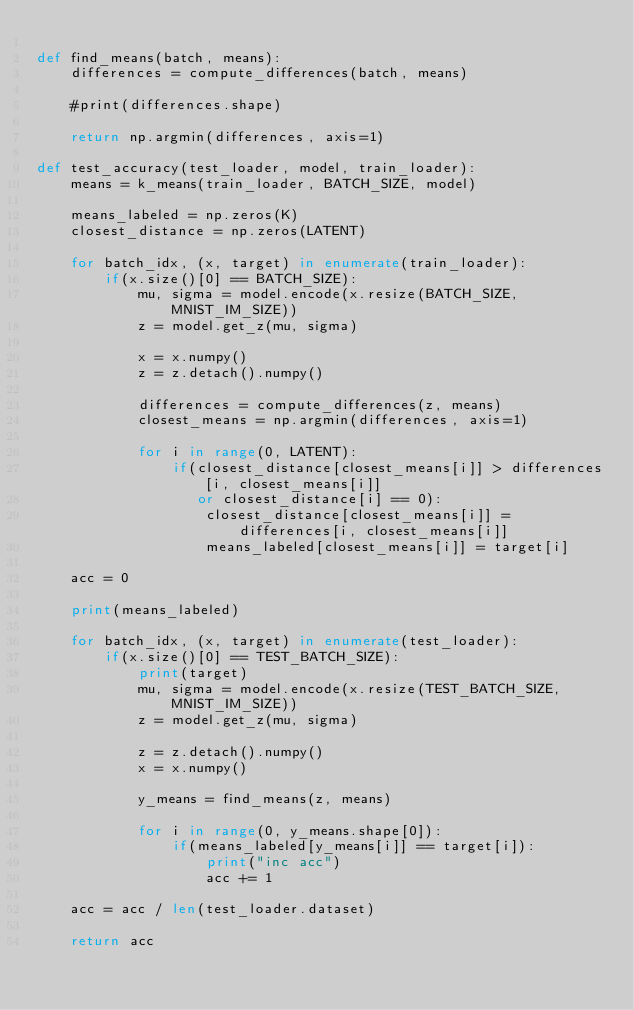<code> <loc_0><loc_0><loc_500><loc_500><_Python_>
def find_means(batch, means):
    differences = compute_differences(batch, means)

    #print(differences.shape)

    return np.argmin(differences, axis=1)

def test_accuracy(test_loader, model, train_loader):
    means = k_means(train_loader, BATCH_SIZE, model)

    means_labeled = np.zeros(K)
    closest_distance = np.zeros(LATENT)

    for batch_idx, (x, target) in enumerate(train_loader):
        if(x.size()[0] == BATCH_SIZE):
            mu, sigma = model.encode(x.resize(BATCH_SIZE, MNIST_IM_SIZE))
            z = model.get_z(mu, sigma)

            x = x.numpy()
            z = z.detach().numpy()

            differences = compute_differences(z, means)
            closest_means = np.argmin(differences, axis=1)

            for i in range(0, LATENT):
                if(closest_distance[closest_means[i]] > differences[i, closest_means[i]]
                   or closest_distance[i] == 0):
                    closest_distance[closest_means[i]] = differences[i, closest_means[i]]
                    means_labeled[closest_means[i]] = target[i]

    acc = 0

    print(means_labeled)

    for batch_idx, (x, target) in enumerate(test_loader):
        if(x.size()[0] == TEST_BATCH_SIZE):
            print(target)
            mu, sigma = model.encode(x.resize(TEST_BATCH_SIZE, MNIST_IM_SIZE))
            z = model.get_z(mu, sigma)

            z = z.detach().numpy()
            x = x.numpy()

            y_means = find_means(z, means)

            for i in range(0, y_means.shape[0]):
                if(means_labeled[y_means[i]] == target[i]):
                    print("inc acc")
                    acc += 1

    acc = acc / len(test_loader.dataset)

    return acc

</code> 